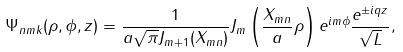Convert formula to latex. <formula><loc_0><loc_0><loc_500><loc_500>\Psi _ { n m k } ( \rho , \phi , z ) = \frac { 1 } { a \sqrt { \pi } J _ { m + 1 } ( X _ { m n } ) } J _ { m } \left ( \frac { X _ { m n } } { a } \rho \right ) e ^ { i m \phi } \frac { e ^ { \pm i q z } } { \sqrt { L } } ,</formula> 